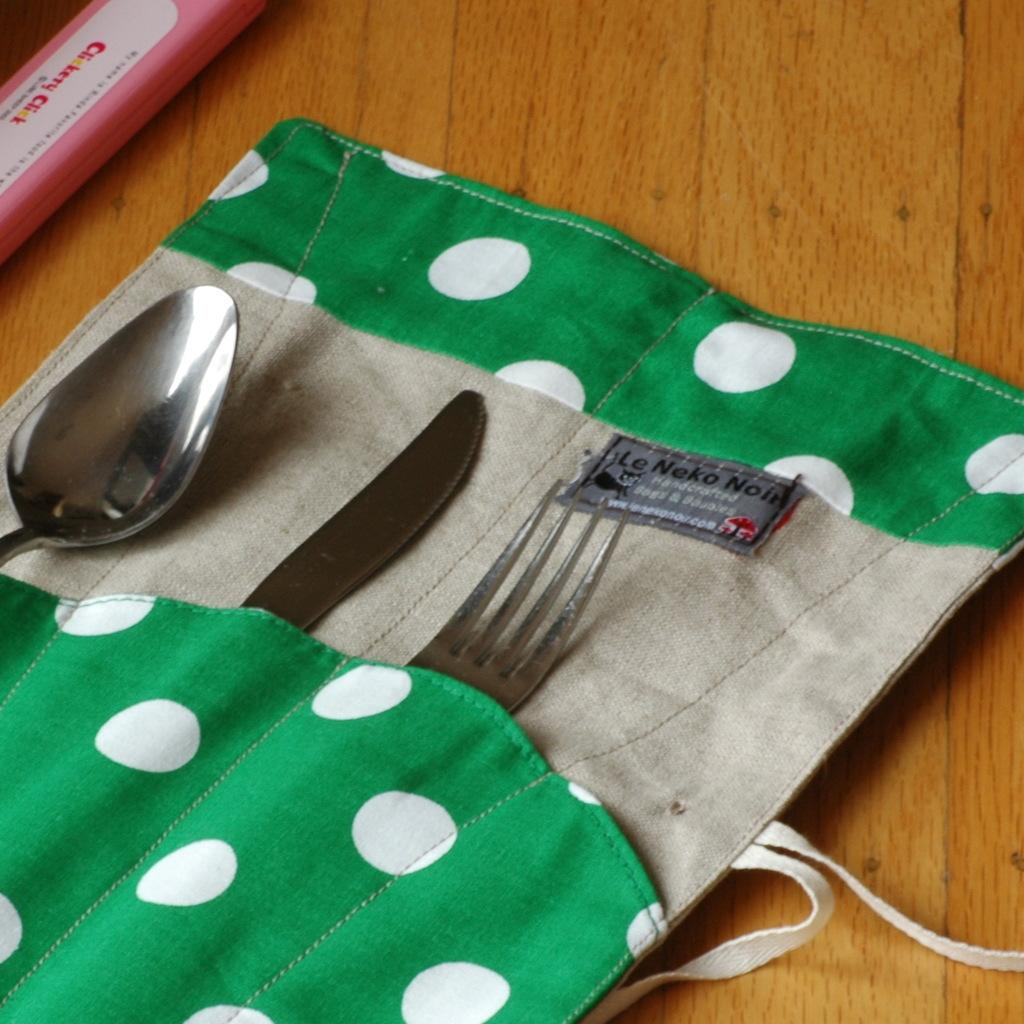What piece of furniture is present in the image? There is a table in the image. What is covering the table? There is a cloth on the table. What utensils can be seen on the table? There is a fork, a knife, and a spoon on the table. What is the income of the person whose face is visible in the image? There is no face visible in the image, and therefore no information about the person's income can be determined. 